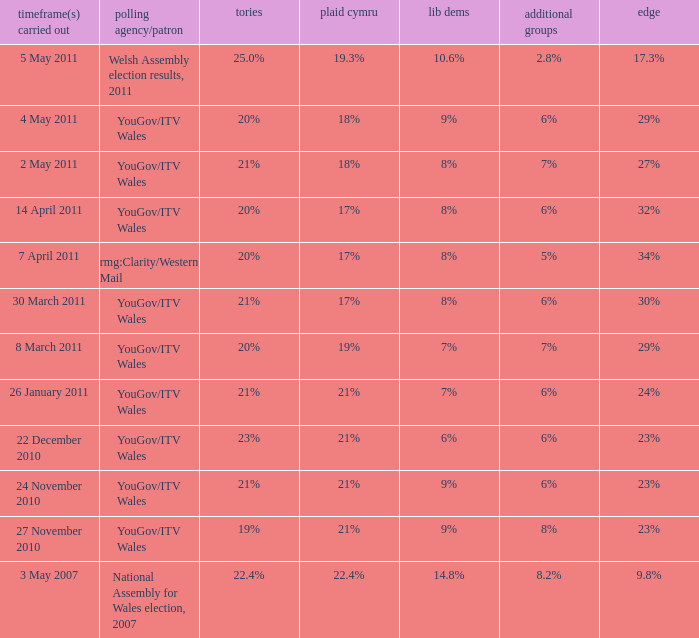Tell me the dates conducted for plaid cymru of 19% 8 March 2011. 